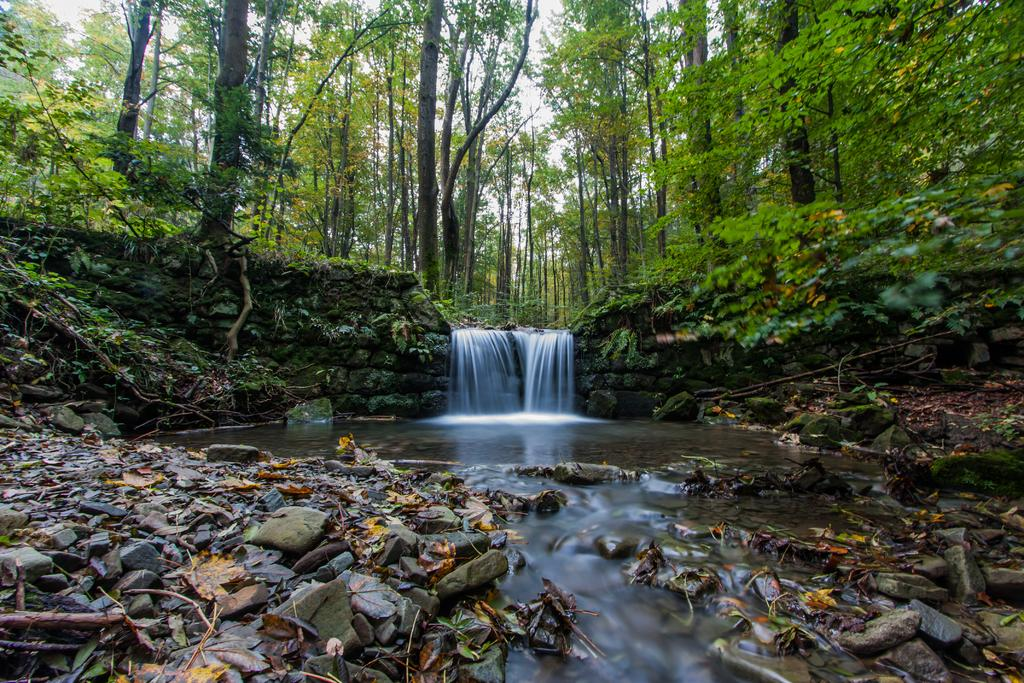What is happening in the image? There is water flow in the image. What type of natural elements can be seen in the image? There are trees and stones present in the image. What is the condition of the leaves on the land in the image? Dry leaves are visible on the land in the image. Where is the gun hidden in the image? There is no gun present in the image. What type of glove can be seen on the tree in the image? There are no gloves present in the image, and trees do not wear gloves. 